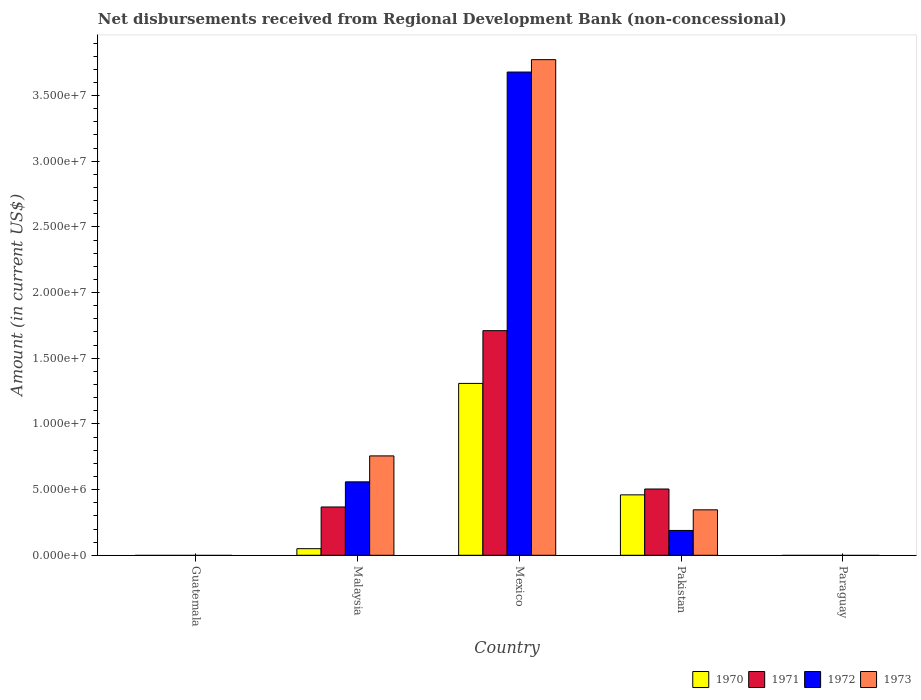How many different coloured bars are there?
Your answer should be very brief. 4. Are the number of bars per tick equal to the number of legend labels?
Make the answer very short. No. How many bars are there on the 1st tick from the right?
Make the answer very short. 0. What is the label of the 2nd group of bars from the left?
Provide a succinct answer. Malaysia. What is the amount of disbursements received from Regional Development Bank in 1971 in Mexico?
Your answer should be compact. 1.71e+07. Across all countries, what is the maximum amount of disbursements received from Regional Development Bank in 1972?
Provide a succinct answer. 3.68e+07. Across all countries, what is the minimum amount of disbursements received from Regional Development Bank in 1971?
Your answer should be compact. 0. In which country was the amount of disbursements received from Regional Development Bank in 1973 maximum?
Your answer should be very brief. Mexico. What is the total amount of disbursements received from Regional Development Bank in 1973 in the graph?
Give a very brief answer. 4.88e+07. What is the difference between the amount of disbursements received from Regional Development Bank in 1970 in Malaysia and that in Pakistan?
Offer a very short reply. -4.10e+06. What is the difference between the amount of disbursements received from Regional Development Bank in 1971 in Pakistan and the amount of disbursements received from Regional Development Bank in 1973 in Malaysia?
Ensure brevity in your answer.  -2.52e+06. What is the average amount of disbursements received from Regional Development Bank in 1972 per country?
Your response must be concise. 8.85e+06. What is the difference between the amount of disbursements received from Regional Development Bank of/in 1973 and amount of disbursements received from Regional Development Bank of/in 1972 in Pakistan?
Give a very brief answer. 1.57e+06. What is the ratio of the amount of disbursements received from Regional Development Bank in 1973 in Malaysia to that in Pakistan?
Offer a very short reply. 2.19. What is the difference between the highest and the second highest amount of disbursements received from Regional Development Bank in 1970?
Make the answer very short. 1.26e+07. What is the difference between the highest and the lowest amount of disbursements received from Regional Development Bank in 1972?
Keep it short and to the point. 3.68e+07. Is it the case that in every country, the sum of the amount of disbursements received from Regional Development Bank in 1973 and amount of disbursements received from Regional Development Bank in 1972 is greater than the amount of disbursements received from Regional Development Bank in 1971?
Provide a succinct answer. No. Are the values on the major ticks of Y-axis written in scientific E-notation?
Your answer should be compact. Yes. Does the graph contain any zero values?
Your response must be concise. Yes. Where does the legend appear in the graph?
Make the answer very short. Bottom right. How are the legend labels stacked?
Keep it short and to the point. Horizontal. What is the title of the graph?
Offer a very short reply. Net disbursements received from Regional Development Bank (non-concessional). What is the label or title of the X-axis?
Keep it short and to the point. Country. What is the label or title of the Y-axis?
Keep it short and to the point. Amount (in current US$). What is the Amount (in current US$) of 1970 in Guatemala?
Provide a succinct answer. 0. What is the Amount (in current US$) of 1971 in Guatemala?
Your answer should be compact. 0. What is the Amount (in current US$) in 1970 in Malaysia?
Keep it short and to the point. 5.02e+05. What is the Amount (in current US$) in 1971 in Malaysia?
Keep it short and to the point. 3.68e+06. What is the Amount (in current US$) of 1972 in Malaysia?
Ensure brevity in your answer.  5.59e+06. What is the Amount (in current US$) of 1973 in Malaysia?
Your answer should be very brief. 7.57e+06. What is the Amount (in current US$) of 1970 in Mexico?
Your answer should be very brief. 1.31e+07. What is the Amount (in current US$) in 1971 in Mexico?
Give a very brief answer. 1.71e+07. What is the Amount (in current US$) in 1972 in Mexico?
Offer a very short reply. 3.68e+07. What is the Amount (in current US$) in 1973 in Mexico?
Your answer should be very brief. 3.77e+07. What is the Amount (in current US$) of 1970 in Pakistan?
Your answer should be compact. 4.60e+06. What is the Amount (in current US$) of 1971 in Pakistan?
Keep it short and to the point. 5.04e+06. What is the Amount (in current US$) of 1972 in Pakistan?
Ensure brevity in your answer.  1.89e+06. What is the Amount (in current US$) of 1973 in Pakistan?
Your answer should be compact. 3.46e+06. What is the Amount (in current US$) in 1972 in Paraguay?
Make the answer very short. 0. Across all countries, what is the maximum Amount (in current US$) of 1970?
Your answer should be compact. 1.31e+07. Across all countries, what is the maximum Amount (in current US$) of 1971?
Ensure brevity in your answer.  1.71e+07. Across all countries, what is the maximum Amount (in current US$) of 1972?
Ensure brevity in your answer.  3.68e+07. Across all countries, what is the maximum Amount (in current US$) of 1973?
Offer a very short reply. 3.77e+07. Across all countries, what is the minimum Amount (in current US$) of 1971?
Ensure brevity in your answer.  0. Across all countries, what is the minimum Amount (in current US$) of 1973?
Offer a very short reply. 0. What is the total Amount (in current US$) in 1970 in the graph?
Keep it short and to the point. 1.82e+07. What is the total Amount (in current US$) in 1971 in the graph?
Your response must be concise. 2.58e+07. What is the total Amount (in current US$) of 1972 in the graph?
Give a very brief answer. 4.43e+07. What is the total Amount (in current US$) in 1973 in the graph?
Offer a very short reply. 4.88e+07. What is the difference between the Amount (in current US$) in 1970 in Malaysia and that in Mexico?
Your answer should be very brief. -1.26e+07. What is the difference between the Amount (in current US$) of 1971 in Malaysia and that in Mexico?
Keep it short and to the point. -1.34e+07. What is the difference between the Amount (in current US$) in 1972 in Malaysia and that in Mexico?
Give a very brief answer. -3.12e+07. What is the difference between the Amount (in current US$) of 1973 in Malaysia and that in Mexico?
Give a very brief answer. -3.02e+07. What is the difference between the Amount (in current US$) of 1970 in Malaysia and that in Pakistan?
Make the answer very short. -4.10e+06. What is the difference between the Amount (in current US$) of 1971 in Malaysia and that in Pakistan?
Make the answer very short. -1.37e+06. What is the difference between the Amount (in current US$) in 1972 in Malaysia and that in Pakistan?
Your answer should be very brief. 3.70e+06. What is the difference between the Amount (in current US$) of 1973 in Malaysia and that in Pakistan?
Provide a succinct answer. 4.10e+06. What is the difference between the Amount (in current US$) in 1970 in Mexico and that in Pakistan?
Your answer should be compact. 8.48e+06. What is the difference between the Amount (in current US$) in 1971 in Mexico and that in Pakistan?
Offer a very short reply. 1.21e+07. What is the difference between the Amount (in current US$) of 1972 in Mexico and that in Pakistan?
Offer a terse response. 3.49e+07. What is the difference between the Amount (in current US$) of 1973 in Mexico and that in Pakistan?
Your answer should be compact. 3.43e+07. What is the difference between the Amount (in current US$) of 1970 in Malaysia and the Amount (in current US$) of 1971 in Mexico?
Offer a very short reply. -1.66e+07. What is the difference between the Amount (in current US$) in 1970 in Malaysia and the Amount (in current US$) in 1972 in Mexico?
Offer a terse response. -3.63e+07. What is the difference between the Amount (in current US$) of 1970 in Malaysia and the Amount (in current US$) of 1973 in Mexico?
Your response must be concise. -3.72e+07. What is the difference between the Amount (in current US$) of 1971 in Malaysia and the Amount (in current US$) of 1972 in Mexico?
Offer a terse response. -3.31e+07. What is the difference between the Amount (in current US$) of 1971 in Malaysia and the Amount (in current US$) of 1973 in Mexico?
Provide a succinct answer. -3.41e+07. What is the difference between the Amount (in current US$) in 1972 in Malaysia and the Amount (in current US$) in 1973 in Mexico?
Provide a succinct answer. -3.21e+07. What is the difference between the Amount (in current US$) of 1970 in Malaysia and the Amount (in current US$) of 1971 in Pakistan?
Ensure brevity in your answer.  -4.54e+06. What is the difference between the Amount (in current US$) of 1970 in Malaysia and the Amount (in current US$) of 1972 in Pakistan?
Keep it short and to the point. -1.39e+06. What is the difference between the Amount (in current US$) of 1970 in Malaysia and the Amount (in current US$) of 1973 in Pakistan?
Keep it short and to the point. -2.96e+06. What is the difference between the Amount (in current US$) in 1971 in Malaysia and the Amount (in current US$) in 1972 in Pakistan?
Offer a terse response. 1.79e+06. What is the difference between the Amount (in current US$) in 1971 in Malaysia and the Amount (in current US$) in 1973 in Pakistan?
Give a very brief answer. 2.16e+05. What is the difference between the Amount (in current US$) in 1972 in Malaysia and the Amount (in current US$) in 1973 in Pakistan?
Your response must be concise. 2.13e+06. What is the difference between the Amount (in current US$) in 1970 in Mexico and the Amount (in current US$) in 1971 in Pakistan?
Ensure brevity in your answer.  8.04e+06. What is the difference between the Amount (in current US$) of 1970 in Mexico and the Amount (in current US$) of 1972 in Pakistan?
Provide a succinct answer. 1.12e+07. What is the difference between the Amount (in current US$) of 1970 in Mexico and the Amount (in current US$) of 1973 in Pakistan?
Provide a succinct answer. 9.62e+06. What is the difference between the Amount (in current US$) in 1971 in Mexico and the Amount (in current US$) in 1972 in Pakistan?
Provide a succinct answer. 1.52e+07. What is the difference between the Amount (in current US$) in 1971 in Mexico and the Amount (in current US$) in 1973 in Pakistan?
Your answer should be compact. 1.36e+07. What is the difference between the Amount (in current US$) of 1972 in Mexico and the Amount (in current US$) of 1973 in Pakistan?
Give a very brief answer. 3.33e+07. What is the average Amount (in current US$) of 1970 per country?
Make the answer very short. 3.64e+06. What is the average Amount (in current US$) of 1971 per country?
Offer a very short reply. 5.16e+06. What is the average Amount (in current US$) of 1972 per country?
Make the answer very short. 8.85e+06. What is the average Amount (in current US$) in 1973 per country?
Your response must be concise. 9.75e+06. What is the difference between the Amount (in current US$) in 1970 and Amount (in current US$) in 1971 in Malaysia?
Offer a terse response. -3.18e+06. What is the difference between the Amount (in current US$) in 1970 and Amount (in current US$) in 1972 in Malaysia?
Your answer should be very brief. -5.09e+06. What is the difference between the Amount (in current US$) of 1970 and Amount (in current US$) of 1973 in Malaysia?
Offer a terse response. -7.06e+06. What is the difference between the Amount (in current US$) of 1971 and Amount (in current US$) of 1972 in Malaysia?
Your answer should be compact. -1.91e+06. What is the difference between the Amount (in current US$) in 1971 and Amount (in current US$) in 1973 in Malaysia?
Ensure brevity in your answer.  -3.89e+06. What is the difference between the Amount (in current US$) in 1972 and Amount (in current US$) in 1973 in Malaysia?
Your response must be concise. -1.98e+06. What is the difference between the Amount (in current US$) of 1970 and Amount (in current US$) of 1971 in Mexico?
Your response must be concise. -4.02e+06. What is the difference between the Amount (in current US$) of 1970 and Amount (in current US$) of 1972 in Mexico?
Keep it short and to the point. -2.37e+07. What is the difference between the Amount (in current US$) of 1970 and Amount (in current US$) of 1973 in Mexico?
Provide a short and direct response. -2.46e+07. What is the difference between the Amount (in current US$) in 1971 and Amount (in current US$) in 1972 in Mexico?
Provide a succinct answer. -1.97e+07. What is the difference between the Amount (in current US$) in 1971 and Amount (in current US$) in 1973 in Mexico?
Provide a short and direct response. -2.06e+07. What is the difference between the Amount (in current US$) of 1972 and Amount (in current US$) of 1973 in Mexico?
Offer a terse response. -9.43e+05. What is the difference between the Amount (in current US$) of 1970 and Amount (in current US$) of 1971 in Pakistan?
Your answer should be compact. -4.45e+05. What is the difference between the Amount (in current US$) in 1970 and Amount (in current US$) in 1972 in Pakistan?
Make the answer very short. 2.71e+06. What is the difference between the Amount (in current US$) of 1970 and Amount (in current US$) of 1973 in Pakistan?
Provide a short and direct response. 1.14e+06. What is the difference between the Amount (in current US$) of 1971 and Amount (in current US$) of 1972 in Pakistan?
Make the answer very short. 3.16e+06. What is the difference between the Amount (in current US$) in 1971 and Amount (in current US$) in 1973 in Pakistan?
Your response must be concise. 1.58e+06. What is the difference between the Amount (in current US$) in 1972 and Amount (in current US$) in 1973 in Pakistan?
Provide a short and direct response. -1.57e+06. What is the ratio of the Amount (in current US$) of 1970 in Malaysia to that in Mexico?
Offer a very short reply. 0.04. What is the ratio of the Amount (in current US$) of 1971 in Malaysia to that in Mexico?
Make the answer very short. 0.21. What is the ratio of the Amount (in current US$) of 1972 in Malaysia to that in Mexico?
Your response must be concise. 0.15. What is the ratio of the Amount (in current US$) of 1973 in Malaysia to that in Mexico?
Provide a succinct answer. 0.2. What is the ratio of the Amount (in current US$) of 1970 in Malaysia to that in Pakistan?
Your response must be concise. 0.11. What is the ratio of the Amount (in current US$) of 1971 in Malaysia to that in Pakistan?
Your answer should be compact. 0.73. What is the ratio of the Amount (in current US$) in 1972 in Malaysia to that in Pakistan?
Your answer should be compact. 2.96. What is the ratio of the Amount (in current US$) of 1973 in Malaysia to that in Pakistan?
Ensure brevity in your answer.  2.19. What is the ratio of the Amount (in current US$) of 1970 in Mexico to that in Pakistan?
Your answer should be very brief. 2.84. What is the ratio of the Amount (in current US$) of 1971 in Mexico to that in Pakistan?
Provide a short and direct response. 3.39. What is the ratio of the Amount (in current US$) of 1972 in Mexico to that in Pakistan?
Give a very brief answer. 19.47. What is the ratio of the Amount (in current US$) in 1973 in Mexico to that in Pakistan?
Offer a very short reply. 10.9. What is the difference between the highest and the second highest Amount (in current US$) in 1970?
Give a very brief answer. 8.48e+06. What is the difference between the highest and the second highest Amount (in current US$) in 1971?
Keep it short and to the point. 1.21e+07. What is the difference between the highest and the second highest Amount (in current US$) of 1972?
Keep it short and to the point. 3.12e+07. What is the difference between the highest and the second highest Amount (in current US$) of 1973?
Offer a very short reply. 3.02e+07. What is the difference between the highest and the lowest Amount (in current US$) in 1970?
Offer a terse response. 1.31e+07. What is the difference between the highest and the lowest Amount (in current US$) of 1971?
Your answer should be compact. 1.71e+07. What is the difference between the highest and the lowest Amount (in current US$) in 1972?
Provide a succinct answer. 3.68e+07. What is the difference between the highest and the lowest Amount (in current US$) of 1973?
Give a very brief answer. 3.77e+07. 